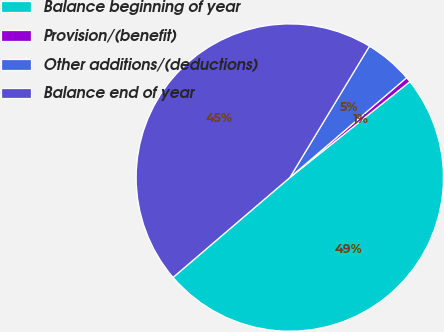<chart> <loc_0><loc_0><loc_500><loc_500><pie_chart><fcel>Balance beginning of year<fcel>Provision/(benefit)<fcel>Other additions/(deductions)<fcel>Balance end of year<nl><fcel>49.47%<fcel>0.53%<fcel>5.07%<fcel>44.93%<nl></chart> 